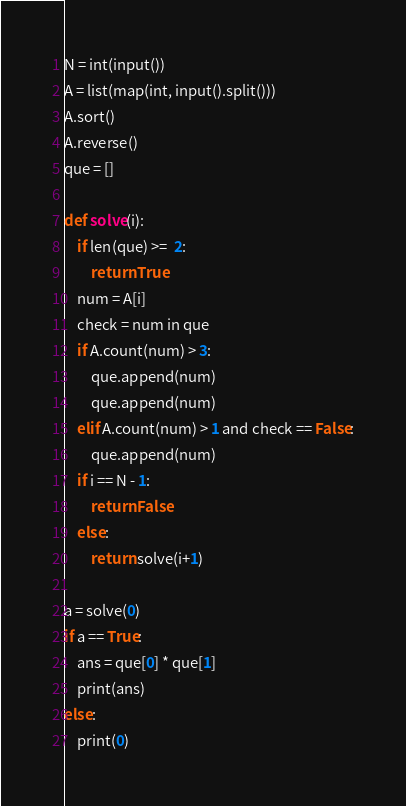Convert code to text. <code><loc_0><loc_0><loc_500><loc_500><_Python_>N = int(input())
A = list(map(int, input().split()))
A.sort()
A.reverse()
que = []

def solve(i):
    if len(que) >=  2:
        return True
    num = A[i]
    check = num in que
    if A.count(num) > 3:
        que.append(num)
        que.append(num)
    elif A.count(num) > 1 and check == False:
        que.append(num)
    if i == N - 1:
        return False
    else:
        return solve(i+1)

a = solve(0)
if a == True:
    ans = que[0] * que[1]
    print(ans)
else:
    print(0)
</code> 